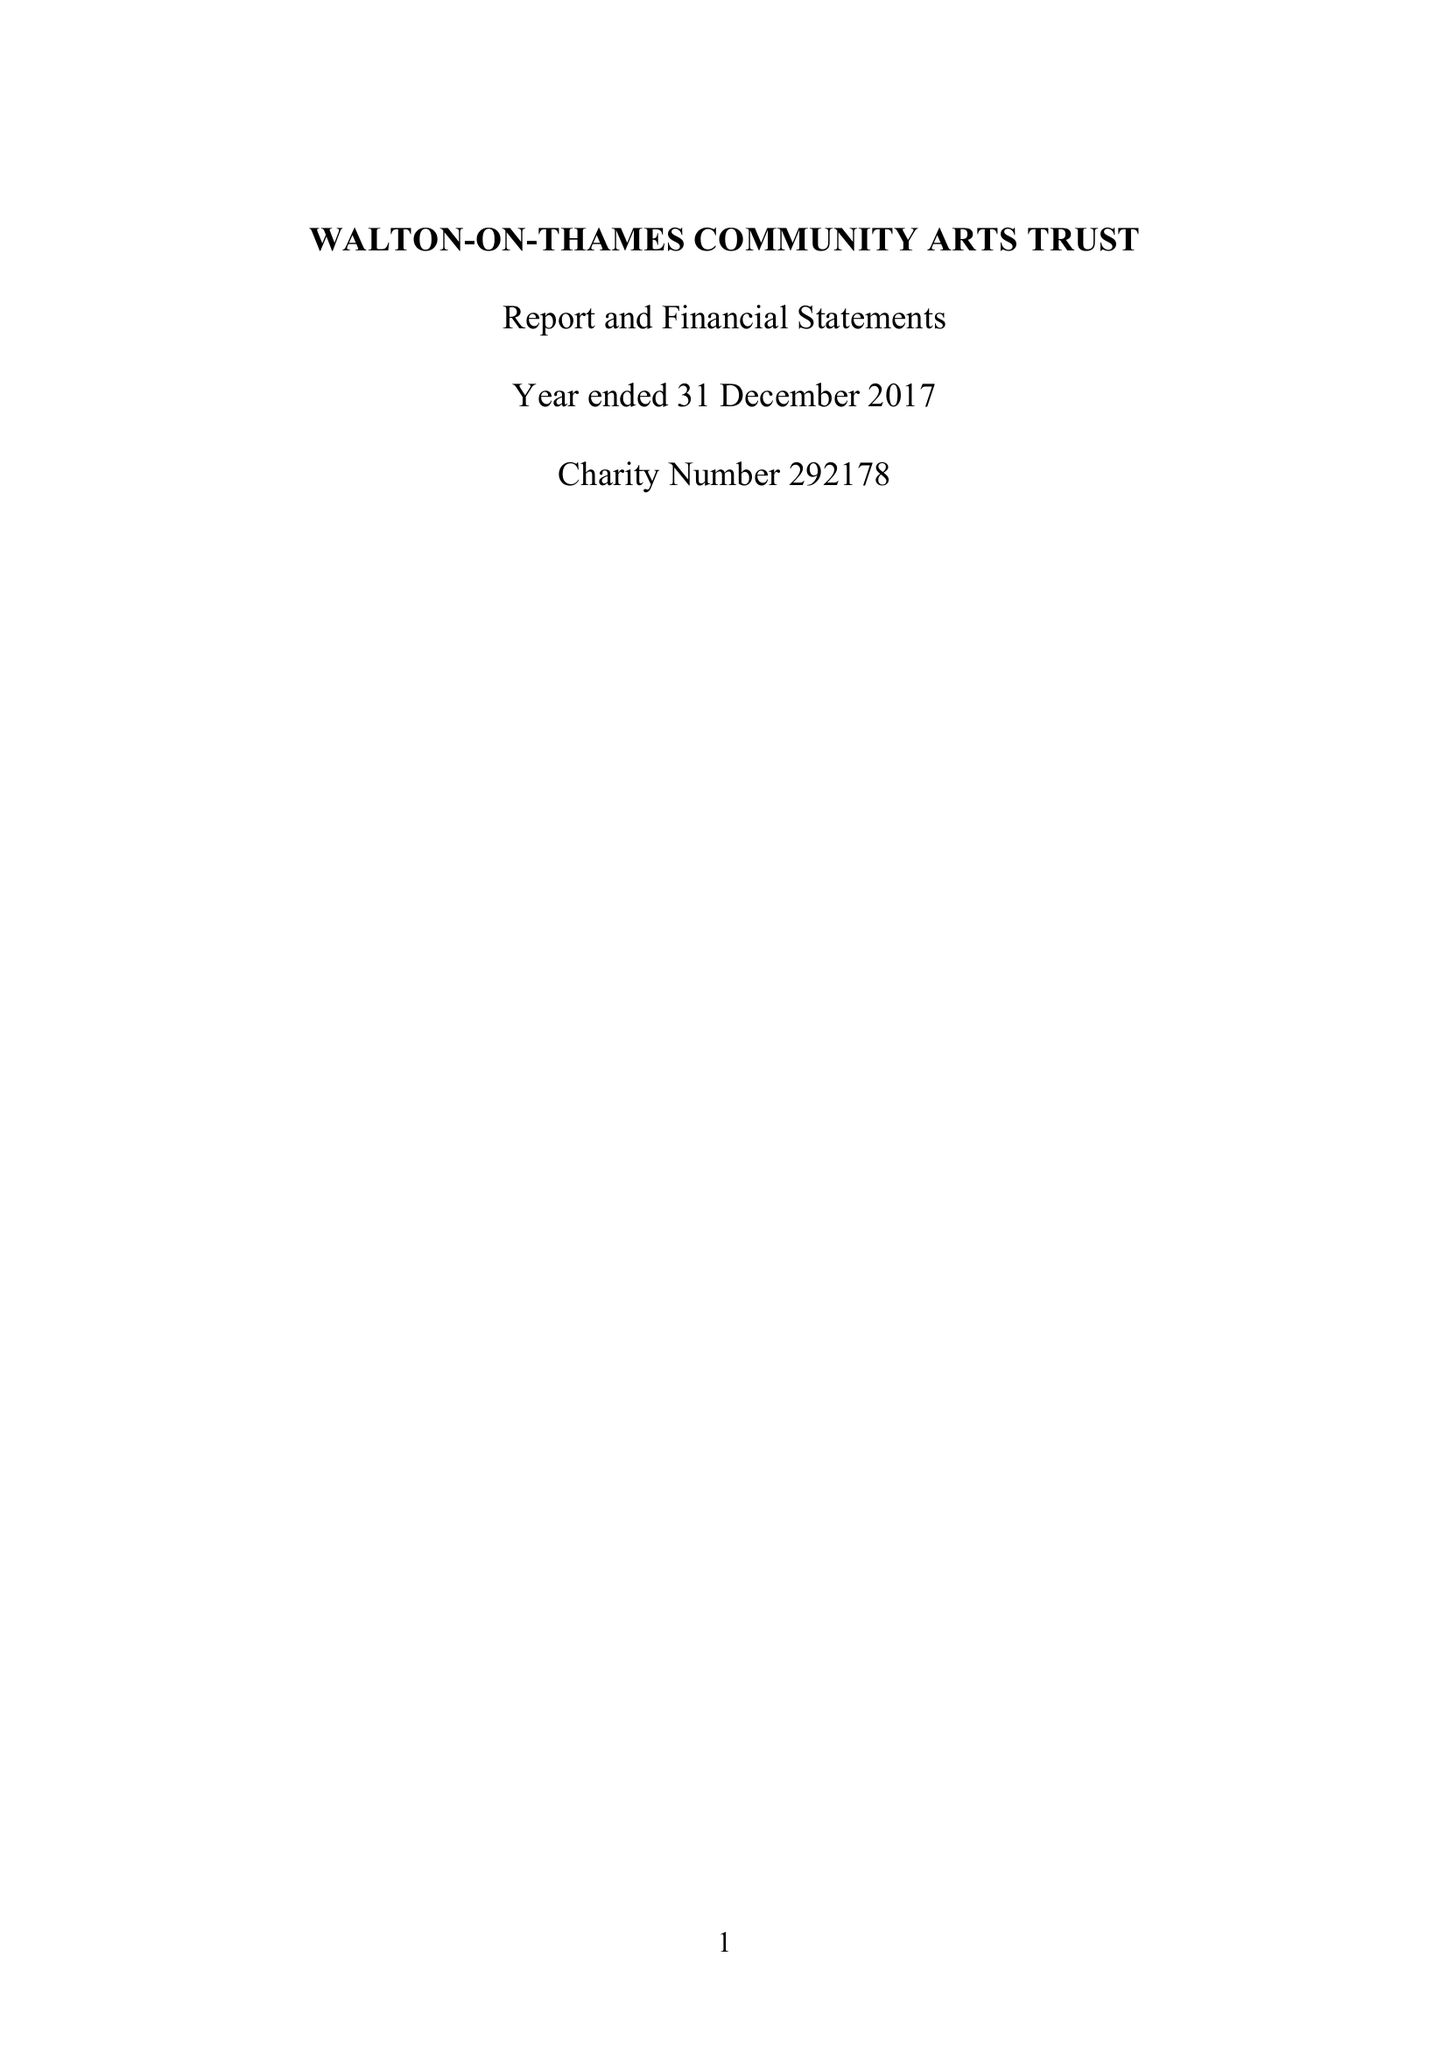What is the value for the charity_name?
Answer the question using a single word or phrase. Walton-On-Thames Community Arts Trust 